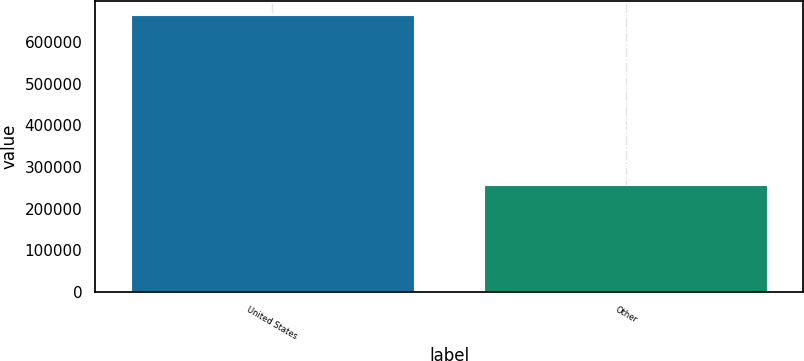Convert chart to OTSL. <chart><loc_0><loc_0><loc_500><loc_500><bar_chart><fcel>United States<fcel>Other<nl><fcel>665219<fcel>256237<nl></chart> 